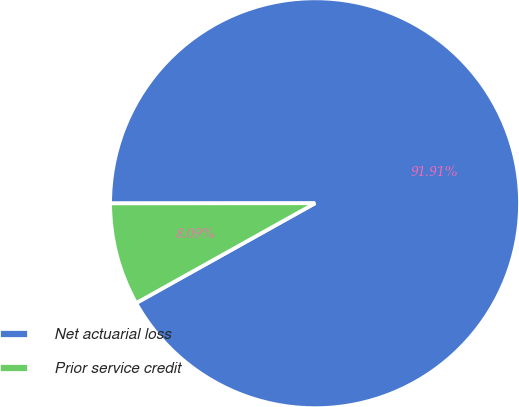Convert chart. <chart><loc_0><loc_0><loc_500><loc_500><pie_chart><fcel>Net actuarial loss<fcel>Prior service credit<nl><fcel>91.91%<fcel>8.09%<nl></chart> 